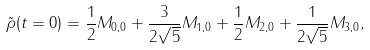Convert formula to latex. <formula><loc_0><loc_0><loc_500><loc_500>\tilde { \rho } ( t = 0 ) = \frac { 1 } { 2 } M _ { 0 , 0 } + \frac { 3 } { 2 \sqrt { 5 } } M _ { 1 , 0 } + \frac { 1 } { 2 } M _ { 2 , 0 } + \frac { 1 } { 2 \sqrt { 5 } } M _ { 3 , 0 } ,</formula> 